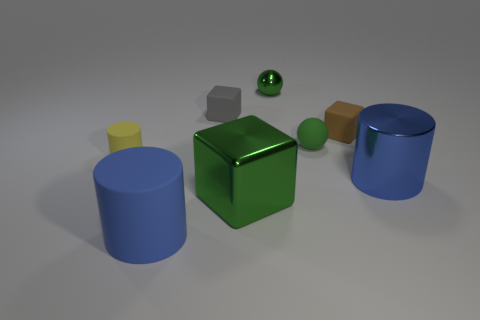Subtract all small gray blocks. How many blocks are left? 2 Subtract 1 blocks. How many blocks are left? 2 Subtract all green cubes. How many blue cylinders are left? 2 Add 1 blue metallic objects. How many objects exist? 9 Subtract all cylinders. How many objects are left? 5 Add 4 tiny brown cubes. How many tiny brown cubes are left? 5 Add 6 red rubber blocks. How many red rubber blocks exist? 6 Subtract 0 purple cylinders. How many objects are left? 8 Subtract all yellow cylinders. Subtract all purple blocks. How many cylinders are left? 2 Subtract all blue balls. Subtract all small brown cubes. How many objects are left? 7 